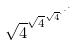Convert formula to latex. <formula><loc_0><loc_0><loc_500><loc_500>\sqrt { 4 } ^ { \sqrt { 4 } ^ { \sqrt { 4 } ^ { \cdot ^ { \cdot ^ { \cdot } } } } }</formula> 